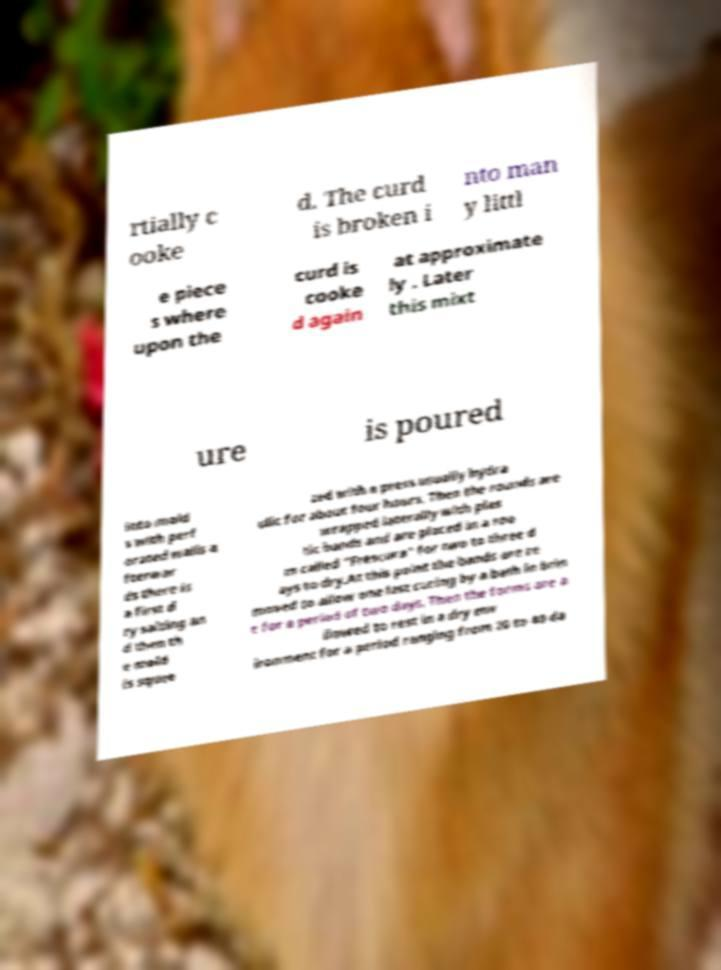Could you assist in decoding the text presented in this image and type it out clearly? rtially c ooke d. The curd is broken i nto man y littl e piece s where upon the curd is cooke d again at approximate ly . Later this mixt ure is poured into mold s with perf orated walls a fterwar ds there is a first d ry salting an d then th e mold is squee zed with a press usually hydra ulic for about four hours. Then the rounds are wrapped laterally with plas tic bands and are placed in a roo m called "Frescura" for two to three d ays to dry.At this point the bands are re moved to allow one last curing by a bath in brin e for a period of two days. Then the forms are a llowed to rest in a dry env ironment for a period ranging from 20 to 40 da 